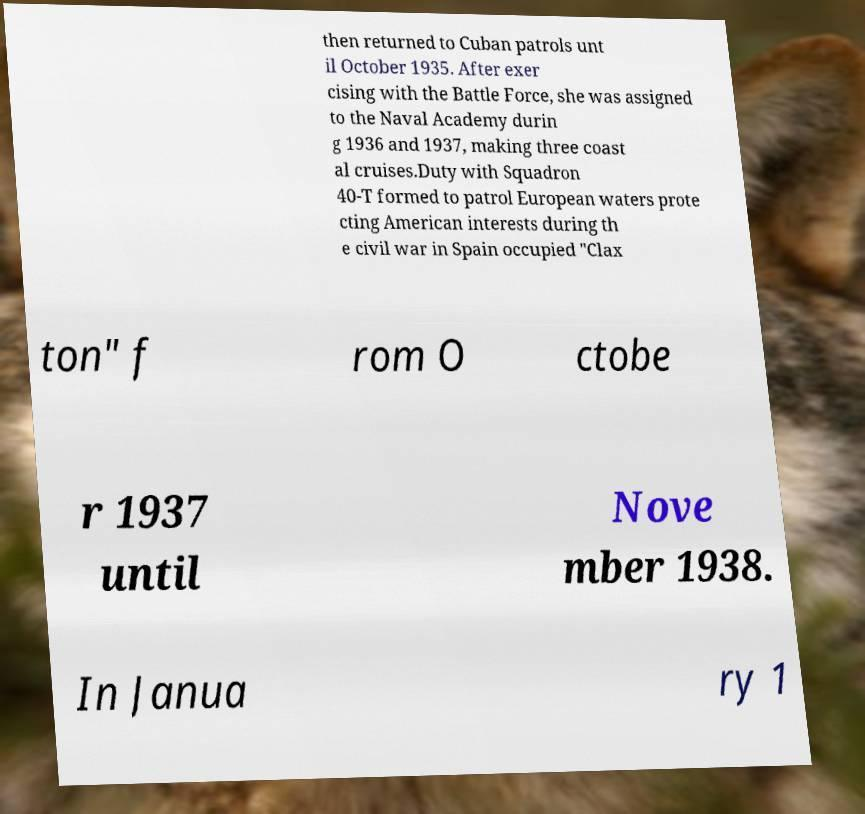Can you read and provide the text displayed in the image?This photo seems to have some interesting text. Can you extract and type it out for me? then returned to Cuban patrols unt il October 1935. After exer cising with the Battle Force, she was assigned to the Naval Academy durin g 1936 and 1937, making three coast al cruises.Duty with Squadron 40-T formed to patrol European waters prote cting American interests during th e civil war in Spain occupied "Clax ton" f rom O ctobe r 1937 until Nove mber 1938. In Janua ry 1 